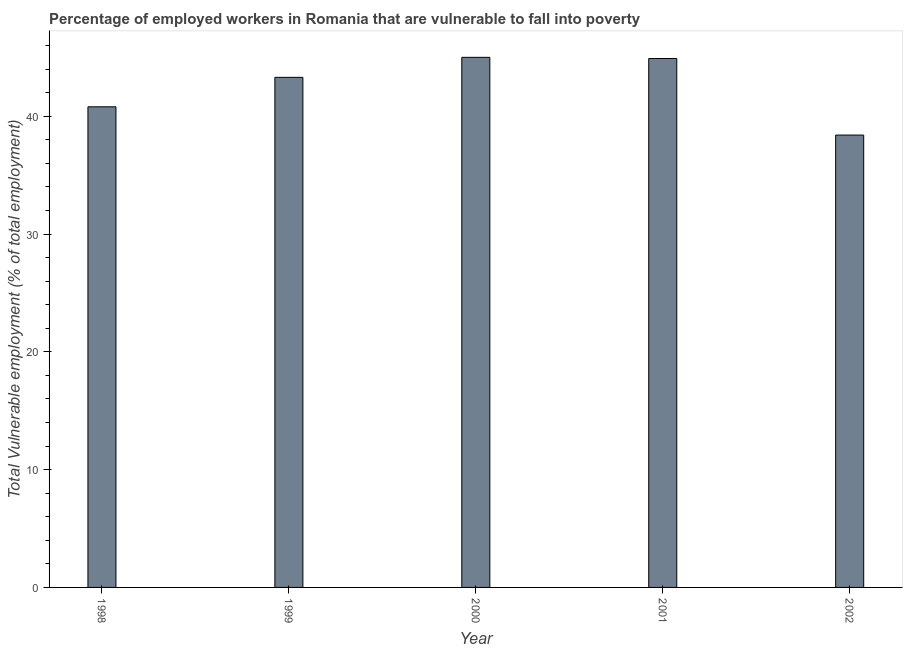What is the title of the graph?
Your answer should be very brief. Percentage of employed workers in Romania that are vulnerable to fall into poverty. What is the label or title of the X-axis?
Give a very brief answer. Year. What is the label or title of the Y-axis?
Give a very brief answer. Total Vulnerable employment (% of total employment). Across all years, what is the maximum total vulnerable employment?
Your response must be concise. 45. Across all years, what is the minimum total vulnerable employment?
Give a very brief answer. 38.4. In which year was the total vulnerable employment maximum?
Make the answer very short. 2000. What is the sum of the total vulnerable employment?
Keep it short and to the point. 212.4. What is the difference between the total vulnerable employment in 2001 and 2002?
Offer a terse response. 6.5. What is the average total vulnerable employment per year?
Ensure brevity in your answer.  42.48. What is the median total vulnerable employment?
Your answer should be compact. 43.3. In how many years, is the total vulnerable employment greater than 20 %?
Your response must be concise. 5. Do a majority of the years between 1998 and 2000 (inclusive) have total vulnerable employment greater than 6 %?
Give a very brief answer. Yes. What is the ratio of the total vulnerable employment in 1999 to that in 2002?
Provide a short and direct response. 1.13. Is the total vulnerable employment in 2001 less than that in 2002?
Give a very brief answer. No. Is the difference between the total vulnerable employment in 1999 and 2000 greater than the difference between any two years?
Offer a very short reply. No. What is the difference between the highest and the second highest total vulnerable employment?
Your answer should be compact. 0.1. How many bars are there?
Offer a terse response. 5. Are all the bars in the graph horizontal?
Your answer should be compact. No. What is the difference between two consecutive major ticks on the Y-axis?
Ensure brevity in your answer.  10. What is the Total Vulnerable employment (% of total employment) of 1998?
Your answer should be compact. 40.8. What is the Total Vulnerable employment (% of total employment) in 1999?
Offer a terse response. 43.3. What is the Total Vulnerable employment (% of total employment) of 2000?
Your answer should be very brief. 45. What is the Total Vulnerable employment (% of total employment) in 2001?
Your response must be concise. 44.9. What is the Total Vulnerable employment (% of total employment) of 2002?
Offer a very short reply. 38.4. What is the difference between the Total Vulnerable employment (% of total employment) in 1998 and 2000?
Your answer should be compact. -4.2. What is the difference between the Total Vulnerable employment (% of total employment) in 1999 and 2000?
Offer a very short reply. -1.7. What is the difference between the Total Vulnerable employment (% of total employment) in 2000 and 2002?
Keep it short and to the point. 6.6. What is the difference between the Total Vulnerable employment (% of total employment) in 2001 and 2002?
Your answer should be very brief. 6.5. What is the ratio of the Total Vulnerable employment (% of total employment) in 1998 to that in 1999?
Ensure brevity in your answer.  0.94. What is the ratio of the Total Vulnerable employment (% of total employment) in 1998 to that in 2000?
Your answer should be very brief. 0.91. What is the ratio of the Total Vulnerable employment (% of total employment) in 1998 to that in 2001?
Offer a very short reply. 0.91. What is the ratio of the Total Vulnerable employment (% of total employment) in 1998 to that in 2002?
Keep it short and to the point. 1.06. What is the ratio of the Total Vulnerable employment (% of total employment) in 1999 to that in 2000?
Your answer should be compact. 0.96. What is the ratio of the Total Vulnerable employment (% of total employment) in 1999 to that in 2002?
Make the answer very short. 1.13. What is the ratio of the Total Vulnerable employment (% of total employment) in 2000 to that in 2001?
Ensure brevity in your answer.  1. What is the ratio of the Total Vulnerable employment (% of total employment) in 2000 to that in 2002?
Make the answer very short. 1.17. What is the ratio of the Total Vulnerable employment (% of total employment) in 2001 to that in 2002?
Ensure brevity in your answer.  1.17. 